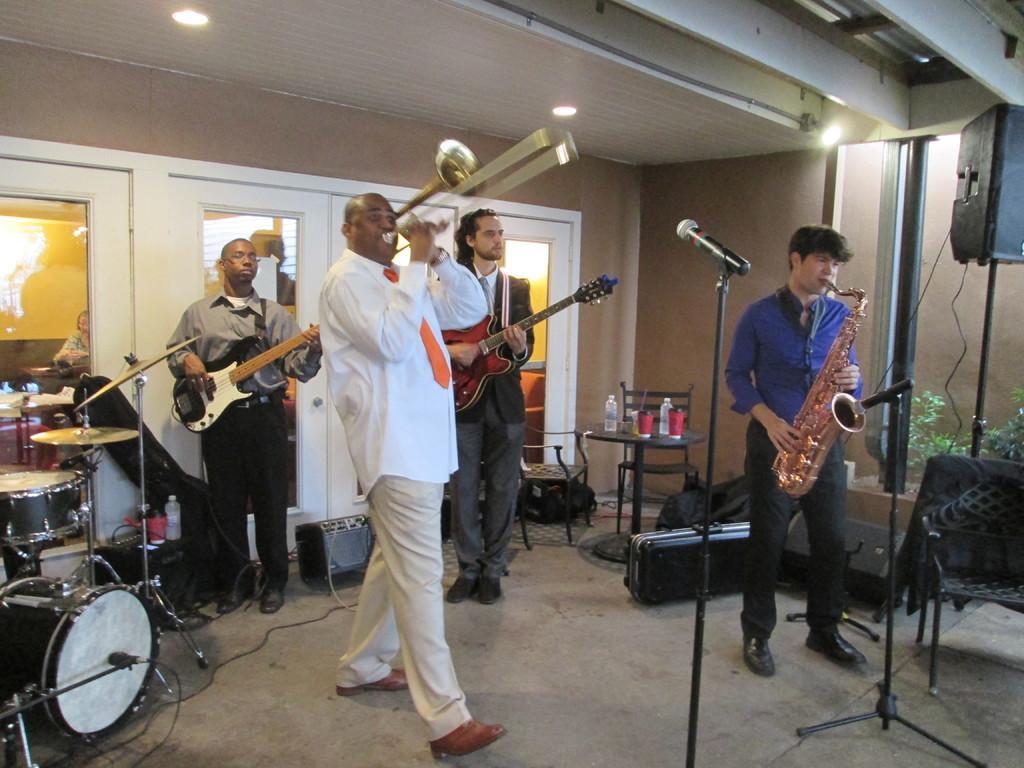In one or two sentences, can you explain what this image depicts? There are four members in this picture standing and playing a different types of musical instruments in front of a mics. In the left side there is a drums. In the background there is a table on which some bottles were placed and a wall here. 